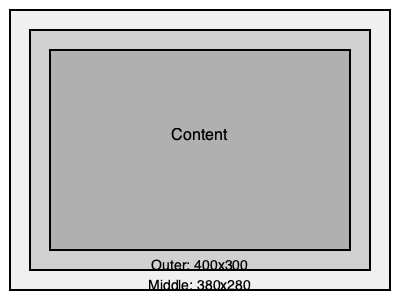Given the nested div structure shown in the diagram, where the outer div has a width of 400px and a height of 300px, and each nested div has a padding of 20px on all sides, what is the width and height of the innermost div's content area? To calculate the dimensions of the innermost div's content area, we need to consider the padding of each nested div:

1. Start with the outer div dimensions: 400px x 300px

2. Calculate the middle div's dimensions:
   - Width: $400px - (2 \times 20px) = 360px$
   - Height: $300px - (2 \times 20px) = 260px$

3. Calculate the inner div's dimensions:
   - Width: $360px - (2 \times 20px) = 320px$
   - Height: $260px - (2 \times 20px) = 220px$

4. Calculate the content area of the innermost div:
   - Width: $320px - (2 \times 20px) = 280px$
   - Height: $220px - (2 \times 20px) = 180px$

Therefore, the content area of the innermost div is 280px wide and 180px high.
Answer: 280px x 180px 